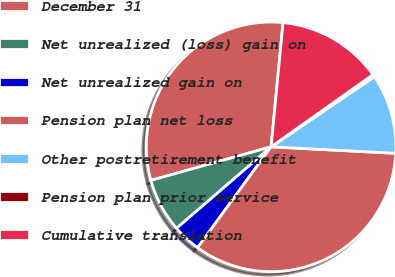Convert chart. <chart><loc_0><loc_0><loc_500><loc_500><pie_chart><fcel>December 31<fcel>Net unrealized (loss) gain on<fcel>Net unrealized gain on<fcel>Pension plan net loss<fcel>Other postretirement benefit<fcel>Pension plan prior service<fcel>Cumulative translation<nl><fcel>30.86%<fcel>6.99%<fcel>3.65%<fcel>34.2%<fcel>10.32%<fcel>0.32%<fcel>13.66%<nl></chart> 